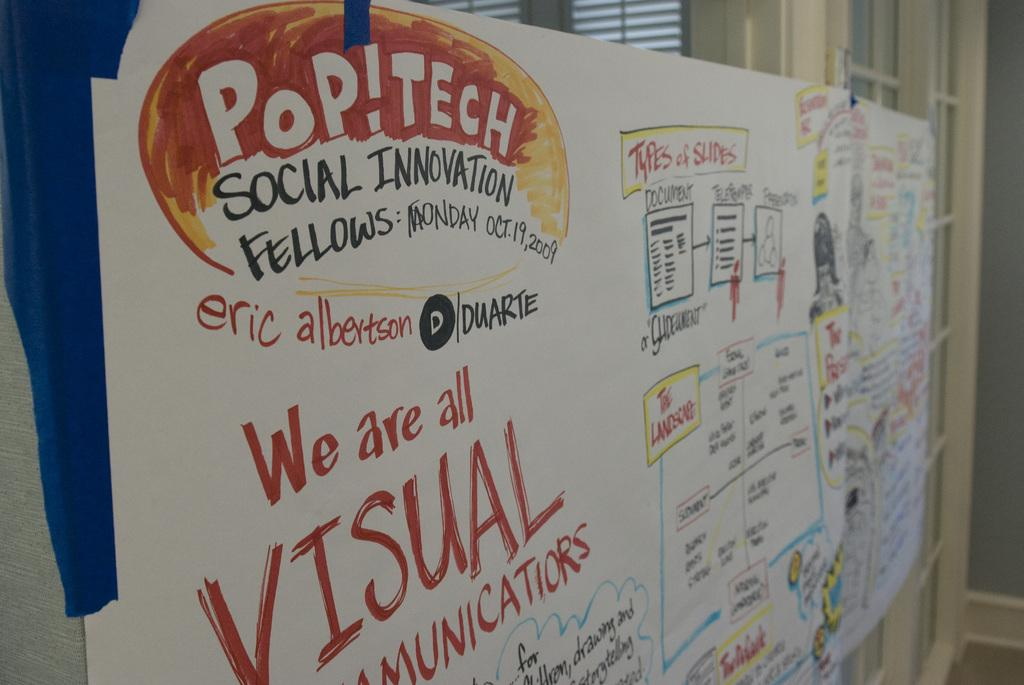Provide a one-sentence caption for the provided image. a POP!TECH Social Invitation sign with lots of other writing on it. 